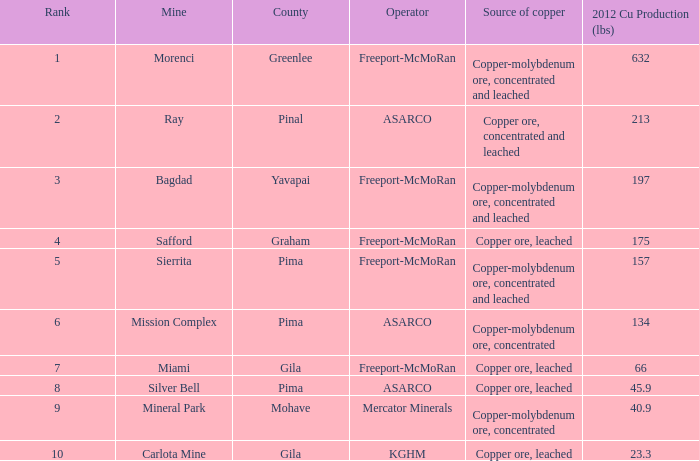Which operator holds the position of 7 in rank? Freeport-McMoRan. 